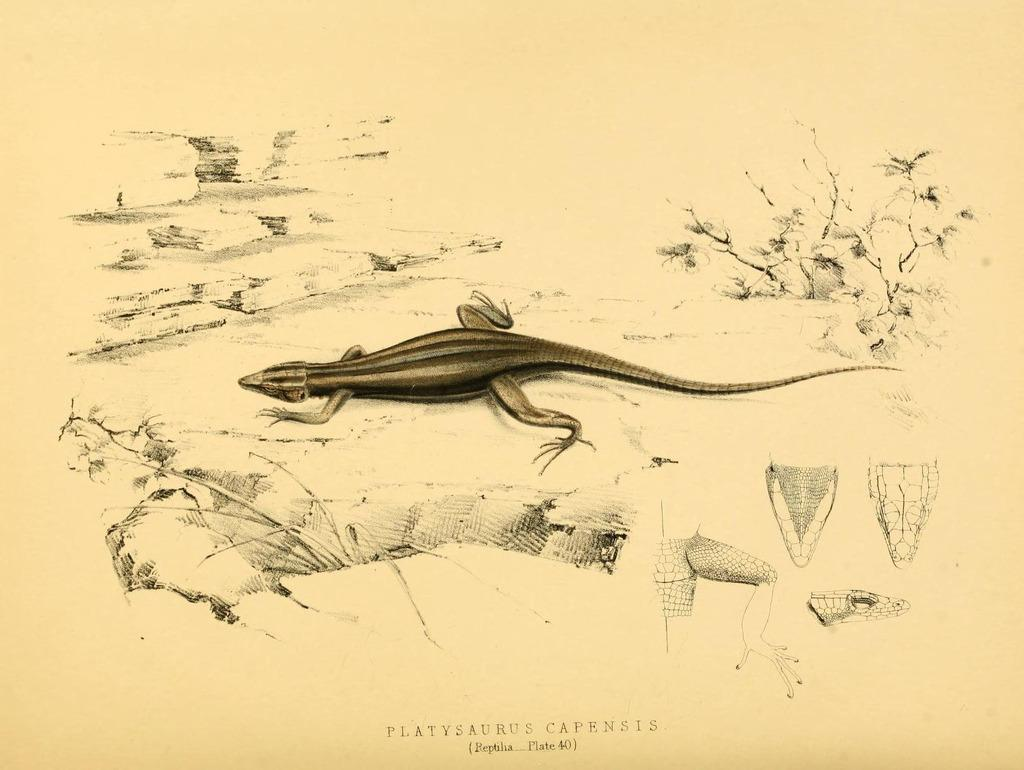What is featured on the poster in the image? The poster contains a reptile. Are there any other elements on the poster besides the reptile? Yes, there are other objects on the poster. Where is the text located on the poster? The text is at the bottom of the poster. How many cows can be seen swimming in the lake on the poster? There are no cows or lake present on the poster; it features a reptile and other objects. 